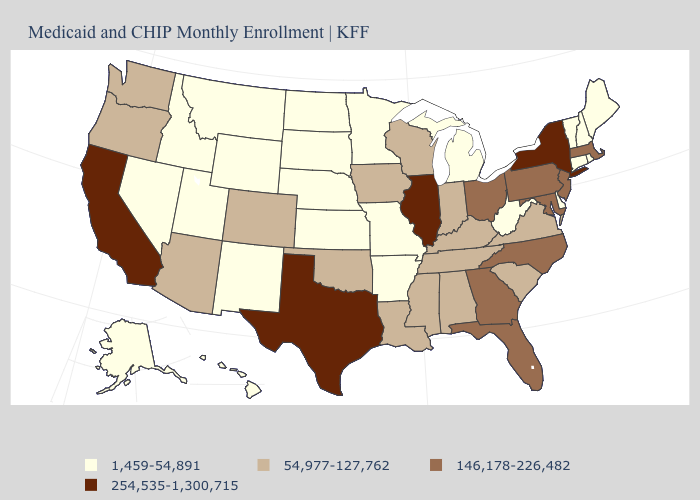Does Oregon have the lowest value in the West?
Short answer required. No. Name the states that have a value in the range 1,459-54,891?
Write a very short answer. Alaska, Arkansas, Connecticut, Delaware, Hawaii, Idaho, Kansas, Maine, Michigan, Minnesota, Missouri, Montana, Nebraska, Nevada, New Hampshire, New Mexico, North Dakota, Rhode Island, South Dakota, Utah, Vermont, West Virginia, Wyoming. Does Delaware have the same value as Missouri?
Short answer required. Yes. What is the value of New Jersey?
Quick response, please. 146,178-226,482. Which states hav the highest value in the South?
Concise answer only. Texas. What is the value of Arkansas?
Answer briefly. 1,459-54,891. What is the highest value in the USA?
Keep it brief. 254,535-1,300,715. What is the lowest value in the USA?
Answer briefly. 1,459-54,891. Name the states that have a value in the range 1,459-54,891?
Be succinct. Alaska, Arkansas, Connecticut, Delaware, Hawaii, Idaho, Kansas, Maine, Michigan, Minnesota, Missouri, Montana, Nebraska, Nevada, New Hampshire, New Mexico, North Dakota, Rhode Island, South Dakota, Utah, Vermont, West Virginia, Wyoming. Does Illinois have the highest value in the USA?
Give a very brief answer. Yes. Among the states that border Wyoming , does Colorado have the highest value?
Keep it brief. Yes. Does New Hampshire have the highest value in the Northeast?
Short answer required. No. What is the value of Iowa?
Give a very brief answer. 54,977-127,762. What is the value of Kentucky?
Write a very short answer. 54,977-127,762. Does Hawaii have the lowest value in the USA?
Write a very short answer. Yes. 